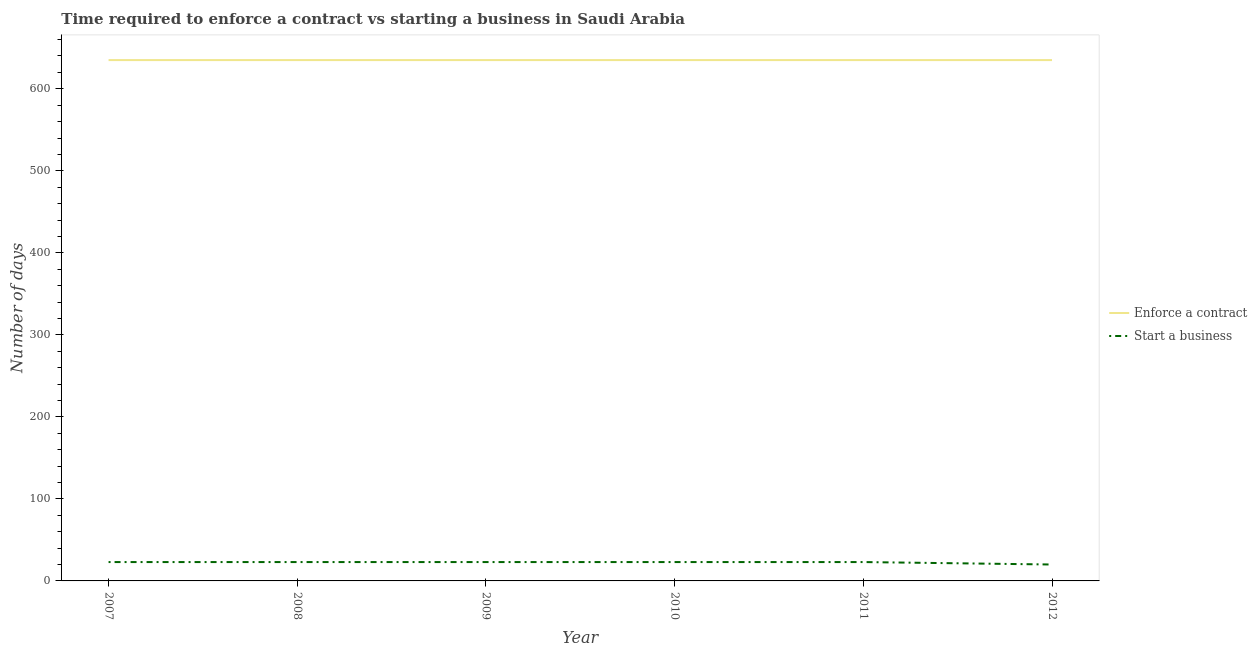How many different coloured lines are there?
Ensure brevity in your answer.  2. Across all years, what is the maximum number of days to enforece a contract?
Your response must be concise. 635. Across all years, what is the minimum number of days to enforece a contract?
Provide a succinct answer. 635. What is the total number of days to enforece a contract in the graph?
Give a very brief answer. 3810. What is the difference between the number of days to start a business in 2009 and that in 2012?
Your response must be concise. 3. What is the difference between the number of days to start a business in 2009 and the number of days to enforece a contract in 2008?
Your answer should be very brief. -612. What is the average number of days to enforece a contract per year?
Your answer should be very brief. 635. In the year 2011, what is the difference between the number of days to enforece a contract and number of days to start a business?
Provide a succinct answer. 612. What is the ratio of the number of days to start a business in 2008 to that in 2009?
Offer a terse response. 1. Is the number of days to start a business in 2009 less than that in 2012?
Give a very brief answer. No. What is the difference between the highest and the second highest number of days to start a business?
Your answer should be very brief. 0. What is the difference between the highest and the lowest number of days to enforece a contract?
Your response must be concise. 0. Is the sum of the number of days to start a business in 2009 and 2012 greater than the maximum number of days to enforece a contract across all years?
Give a very brief answer. No. Is the number of days to start a business strictly greater than the number of days to enforece a contract over the years?
Provide a short and direct response. No. Is the number of days to enforece a contract strictly less than the number of days to start a business over the years?
Your response must be concise. No. How many lines are there?
Your answer should be compact. 2. What is the difference between two consecutive major ticks on the Y-axis?
Provide a short and direct response. 100. Does the graph contain any zero values?
Your answer should be very brief. No. Where does the legend appear in the graph?
Offer a terse response. Center right. How many legend labels are there?
Provide a short and direct response. 2. How are the legend labels stacked?
Your response must be concise. Vertical. What is the title of the graph?
Make the answer very short. Time required to enforce a contract vs starting a business in Saudi Arabia. Does "Public funds" appear as one of the legend labels in the graph?
Offer a terse response. No. What is the label or title of the X-axis?
Offer a very short reply. Year. What is the label or title of the Y-axis?
Give a very brief answer. Number of days. What is the Number of days of Enforce a contract in 2007?
Make the answer very short. 635. What is the Number of days in Start a business in 2007?
Keep it short and to the point. 23. What is the Number of days of Enforce a contract in 2008?
Make the answer very short. 635. What is the Number of days in Enforce a contract in 2009?
Give a very brief answer. 635. What is the Number of days in Start a business in 2009?
Provide a short and direct response. 23. What is the Number of days of Enforce a contract in 2010?
Your answer should be very brief. 635. What is the Number of days of Start a business in 2010?
Offer a terse response. 23. What is the Number of days in Enforce a contract in 2011?
Provide a short and direct response. 635. What is the Number of days in Start a business in 2011?
Ensure brevity in your answer.  23. What is the Number of days of Enforce a contract in 2012?
Provide a short and direct response. 635. Across all years, what is the maximum Number of days of Enforce a contract?
Your answer should be very brief. 635. Across all years, what is the minimum Number of days in Enforce a contract?
Keep it short and to the point. 635. Across all years, what is the minimum Number of days in Start a business?
Your answer should be compact. 20. What is the total Number of days in Enforce a contract in the graph?
Offer a very short reply. 3810. What is the total Number of days of Start a business in the graph?
Keep it short and to the point. 135. What is the difference between the Number of days of Enforce a contract in 2007 and that in 2008?
Keep it short and to the point. 0. What is the difference between the Number of days in Start a business in 2007 and that in 2008?
Provide a short and direct response. 0. What is the difference between the Number of days of Start a business in 2007 and that in 2009?
Ensure brevity in your answer.  0. What is the difference between the Number of days in Enforce a contract in 2007 and that in 2010?
Your response must be concise. 0. What is the difference between the Number of days in Start a business in 2007 and that in 2012?
Your answer should be very brief. 3. What is the difference between the Number of days in Enforce a contract in 2008 and that in 2010?
Provide a succinct answer. 0. What is the difference between the Number of days in Start a business in 2008 and that in 2010?
Ensure brevity in your answer.  0. What is the difference between the Number of days of Enforce a contract in 2008 and that in 2011?
Your answer should be very brief. 0. What is the difference between the Number of days of Start a business in 2008 and that in 2012?
Provide a short and direct response. 3. What is the difference between the Number of days of Enforce a contract in 2009 and that in 2010?
Make the answer very short. 0. What is the difference between the Number of days of Start a business in 2009 and that in 2010?
Offer a very short reply. 0. What is the difference between the Number of days in Enforce a contract in 2009 and that in 2011?
Provide a succinct answer. 0. What is the difference between the Number of days in Start a business in 2009 and that in 2012?
Your response must be concise. 3. What is the difference between the Number of days in Enforce a contract in 2010 and that in 2012?
Your answer should be very brief. 0. What is the difference between the Number of days in Enforce a contract in 2011 and that in 2012?
Offer a terse response. 0. What is the difference between the Number of days of Enforce a contract in 2007 and the Number of days of Start a business in 2008?
Offer a terse response. 612. What is the difference between the Number of days of Enforce a contract in 2007 and the Number of days of Start a business in 2009?
Offer a very short reply. 612. What is the difference between the Number of days in Enforce a contract in 2007 and the Number of days in Start a business in 2010?
Offer a very short reply. 612. What is the difference between the Number of days of Enforce a contract in 2007 and the Number of days of Start a business in 2011?
Your response must be concise. 612. What is the difference between the Number of days in Enforce a contract in 2007 and the Number of days in Start a business in 2012?
Ensure brevity in your answer.  615. What is the difference between the Number of days of Enforce a contract in 2008 and the Number of days of Start a business in 2009?
Provide a succinct answer. 612. What is the difference between the Number of days of Enforce a contract in 2008 and the Number of days of Start a business in 2010?
Your answer should be compact. 612. What is the difference between the Number of days of Enforce a contract in 2008 and the Number of days of Start a business in 2011?
Your answer should be compact. 612. What is the difference between the Number of days of Enforce a contract in 2008 and the Number of days of Start a business in 2012?
Offer a terse response. 615. What is the difference between the Number of days of Enforce a contract in 2009 and the Number of days of Start a business in 2010?
Your response must be concise. 612. What is the difference between the Number of days in Enforce a contract in 2009 and the Number of days in Start a business in 2011?
Your response must be concise. 612. What is the difference between the Number of days in Enforce a contract in 2009 and the Number of days in Start a business in 2012?
Provide a short and direct response. 615. What is the difference between the Number of days of Enforce a contract in 2010 and the Number of days of Start a business in 2011?
Your answer should be very brief. 612. What is the difference between the Number of days in Enforce a contract in 2010 and the Number of days in Start a business in 2012?
Your response must be concise. 615. What is the difference between the Number of days in Enforce a contract in 2011 and the Number of days in Start a business in 2012?
Your response must be concise. 615. What is the average Number of days of Enforce a contract per year?
Provide a succinct answer. 635. What is the average Number of days of Start a business per year?
Your answer should be compact. 22.5. In the year 2007, what is the difference between the Number of days in Enforce a contract and Number of days in Start a business?
Your answer should be very brief. 612. In the year 2008, what is the difference between the Number of days of Enforce a contract and Number of days of Start a business?
Provide a short and direct response. 612. In the year 2009, what is the difference between the Number of days in Enforce a contract and Number of days in Start a business?
Your answer should be very brief. 612. In the year 2010, what is the difference between the Number of days of Enforce a contract and Number of days of Start a business?
Your response must be concise. 612. In the year 2011, what is the difference between the Number of days of Enforce a contract and Number of days of Start a business?
Make the answer very short. 612. In the year 2012, what is the difference between the Number of days in Enforce a contract and Number of days in Start a business?
Give a very brief answer. 615. What is the ratio of the Number of days of Start a business in 2007 to that in 2008?
Give a very brief answer. 1. What is the ratio of the Number of days of Enforce a contract in 2007 to that in 2011?
Make the answer very short. 1. What is the ratio of the Number of days in Start a business in 2007 to that in 2011?
Your answer should be very brief. 1. What is the ratio of the Number of days of Enforce a contract in 2007 to that in 2012?
Offer a very short reply. 1. What is the ratio of the Number of days in Start a business in 2007 to that in 2012?
Keep it short and to the point. 1.15. What is the ratio of the Number of days in Start a business in 2008 to that in 2009?
Your answer should be compact. 1. What is the ratio of the Number of days in Enforce a contract in 2008 to that in 2010?
Your response must be concise. 1. What is the ratio of the Number of days of Enforce a contract in 2008 to that in 2011?
Ensure brevity in your answer.  1. What is the ratio of the Number of days in Start a business in 2008 to that in 2011?
Offer a very short reply. 1. What is the ratio of the Number of days of Start a business in 2008 to that in 2012?
Give a very brief answer. 1.15. What is the ratio of the Number of days of Start a business in 2009 to that in 2010?
Keep it short and to the point. 1. What is the ratio of the Number of days of Enforce a contract in 2009 to that in 2011?
Provide a short and direct response. 1. What is the ratio of the Number of days in Start a business in 2009 to that in 2012?
Ensure brevity in your answer.  1.15. What is the ratio of the Number of days in Start a business in 2010 to that in 2012?
Make the answer very short. 1.15. What is the ratio of the Number of days in Start a business in 2011 to that in 2012?
Provide a succinct answer. 1.15. What is the difference between the highest and the second highest Number of days in Enforce a contract?
Your answer should be compact. 0. What is the difference between the highest and the second highest Number of days of Start a business?
Keep it short and to the point. 0. What is the difference between the highest and the lowest Number of days of Start a business?
Give a very brief answer. 3. 